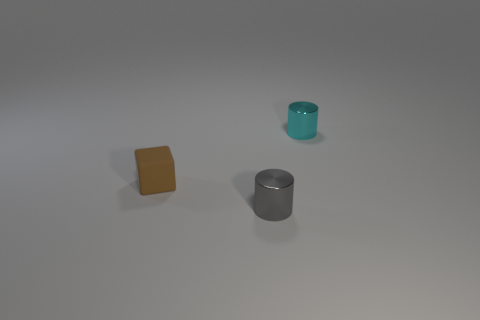Are there any other things that have the same shape as the tiny rubber thing?
Keep it short and to the point. No. Is the shape of the tiny cyan object the same as the rubber object?
Make the answer very short. No. What number of other small things have the same shape as the tiny brown matte object?
Provide a short and direct response. 0. Are there any other small objects of the same shape as the tiny cyan object?
Provide a succinct answer. Yes. The matte object has what color?
Offer a very short reply. Brown. How many matte objects are either red objects or brown objects?
Provide a short and direct response. 1. Are there any other things that have the same material as the brown object?
Provide a short and direct response. No. There is a shiny cylinder that is to the right of the shiny thing that is to the left of the cyan shiny object behind the brown matte block; what is its size?
Your answer should be very brief. Small. There is a thing that is both behind the gray cylinder and right of the small matte thing; what is its size?
Keep it short and to the point. Small. There is a shiny cylinder in front of the small brown matte block; is it the same color as the metallic object behind the small brown rubber block?
Your answer should be compact. No. 